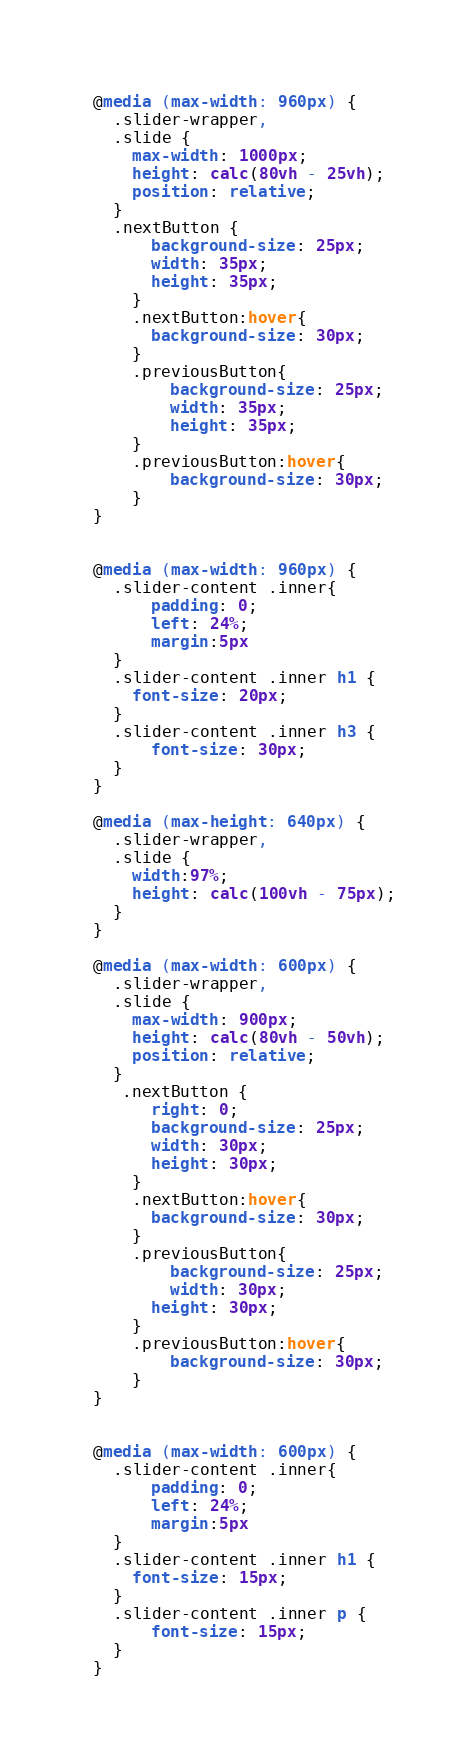<code> <loc_0><loc_0><loc_500><loc_500><_CSS_>
    
  @media (max-width: 960px) {
	.slider-wrapper,
	.slide {
	  max-width: 1000px;
	  height: calc(80vh - 25vh);
	  position: relative;
	}
	.nextButton {
		background-size: 25px;
		width: 35px;
		height: 35px;
	  } 
	  .nextButton:hover{
		background-size: 30px;
	  }
	  .previousButton{
		  background-size: 25px;
		  width: 35px;
		  height: 35px;
	  }
	  .previousButton:hover{
		  background-size: 30px;
	  }
  }

  
  @media (max-width: 960px) {
	.slider-content .inner{
		padding: 0;
		left: 24%;
		margin:5px
	}
	.slider-content .inner h1 {
	  font-size: 20px;
	}
	.slider-content .inner h3 {
		font-size: 30px;
	}
  }
  
  @media (max-height: 640px) {
	.slider-wrapper,
	.slide {
	  width:97%;
	  height: calc(100vh - 75px);
	}
  }
  
  @media (max-width: 600px) {
	.slider-wrapper,
	.slide {
	  max-width: 900px;
	  height: calc(80vh - 50vh);
	  position: relative;
	}
	 .nextButton {
		right: 0;
		background-size: 25px;
		width: 30px;
		height: 30px;
	  } 
	  .nextButton:hover{
		background-size: 30px;
	  }
	  .previousButton{
		  background-size: 25px;
		  width: 30px;
		height: 30px;
	  }
	  .previousButton:hover{
		  background-size: 30px;
	  }
  }

  
  @media (max-width: 600px) {
	.slider-content .inner{
		padding: 0;
		left: 24%;
		margin:5px
	}
	.slider-content .inner h1 {
	  font-size: 15px;
	}
	.slider-content .inner p {
		font-size: 15px;
	}
  }</code> 